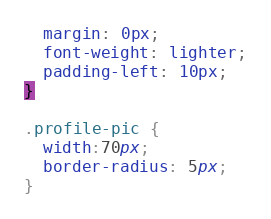Convert code to text. <code><loc_0><loc_0><loc_500><loc_500><_CSS_>  margin: 0px;
  font-weight: lighter;
  padding-left: 10px;
}

.profile-pic {
  width:70px;
  border-radius: 5px;
}
</code> 